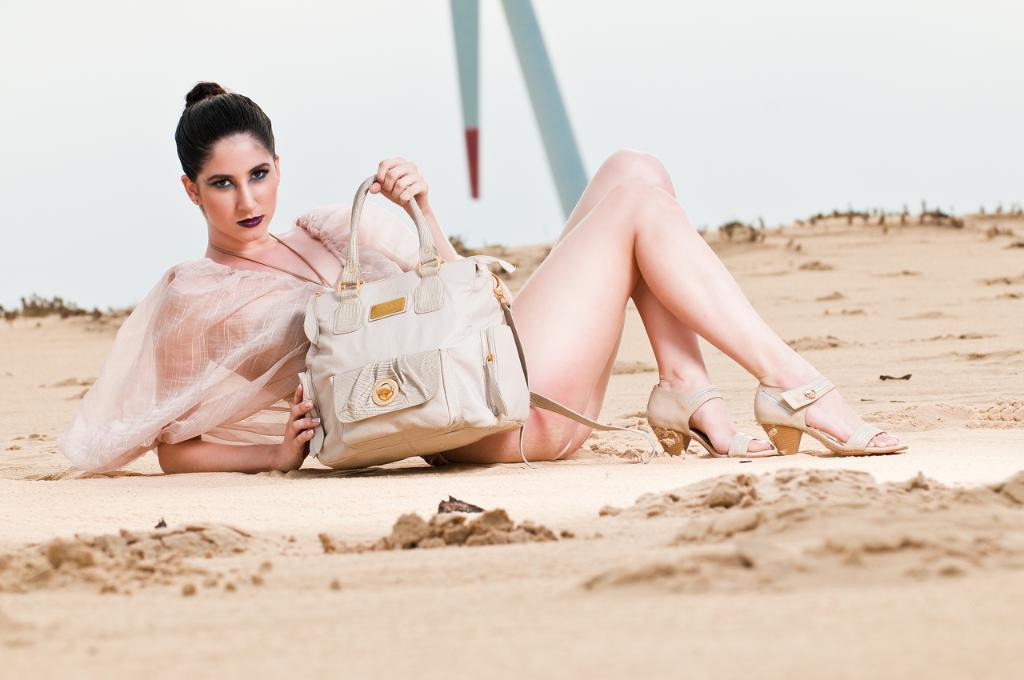What type of setting is depicted in the image? The image is of an outdoor scene. What can be seen in the foreground of the image? There is ground visible in the foreground. What is the woman in the image doing? The woman is sitting on the ground. What is the woman holding in the image? The woman is holding a bag. What can be seen in the background of the image? The sky is visible in the background. What is the price of the guide in the image? There is no guide present in the image, so it is not possible to determine the price. 